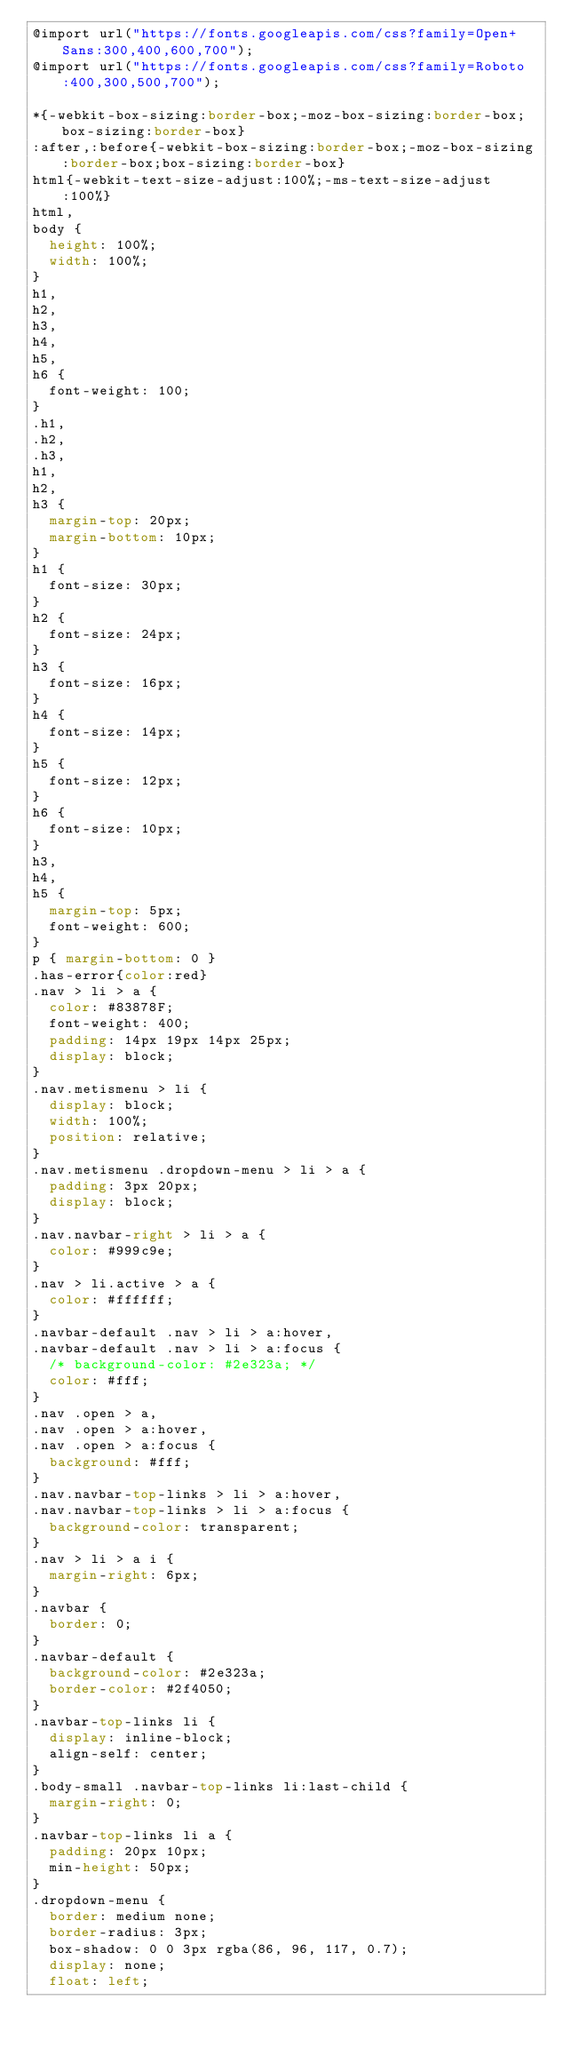<code> <loc_0><loc_0><loc_500><loc_500><_CSS_>@import url("https://fonts.googleapis.com/css?family=Open+Sans:300,400,600,700");
@import url("https://fonts.googleapis.com/css?family=Roboto:400,300,500,700");

*{-webkit-box-sizing:border-box;-moz-box-sizing:border-box;box-sizing:border-box}
:after,:before{-webkit-box-sizing:border-box;-moz-box-sizing:border-box;box-sizing:border-box}
html{-webkit-text-size-adjust:100%;-ms-text-size-adjust:100%}
html,
body {
  height: 100%;
  width: 100%;
}
h1,
h2,
h3,
h4,
h5,
h6 {
  font-weight: 100;
}
.h1,
.h2,
.h3,
h1,
h2,
h3 {
  margin-top: 20px;
  margin-bottom: 10px;
}
h1 {
  font-size: 30px;
}
h2 {
  font-size: 24px;
}
h3 {
  font-size: 16px;
}
h4 {
  font-size: 14px;
}
h5 {
  font-size: 12px;
}
h6 {
  font-size: 10px;
}
h3,
h4,
h5 {
  margin-top: 5px;
  font-weight: 600;
}
p { margin-bottom: 0 }
.has-error{color:red}
.nav > li > a {
  color: #83878F;
  font-weight: 400;
  padding: 14px 19px 14px 25px;
  display: block;
}
.nav.metismenu > li {
  display: block;
  width: 100%;
  position: relative;
}
.nav.metismenu .dropdown-menu > li > a {
  padding: 3px 20px;
  display: block;
}
.nav.navbar-right > li > a {
  color: #999c9e;
}
.nav > li.active > a {
  color: #ffffff;
}
.navbar-default .nav > li > a:hover,
.navbar-default .nav > li > a:focus {
  /* background-color: #2e323a; */
  color: #fff;
}
.nav .open > a,
.nav .open > a:hover,
.nav .open > a:focus {
  background: #fff;
}
.nav.navbar-top-links > li > a:hover,
.nav.navbar-top-links > li > a:focus {
  background-color: transparent;
}
.nav > li > a i {
  margin-right: 6px;
}
.navbar {
  border: 0;
}
.navbar-default {
  background-color: #2e323a;
  border-color: #2f4050;
}
.navbar-top-links li {
  display: inline-block;
  align-self: center;
}
.body-small .navbar-top-links li:last-child {
  margin-right: 0;
}
.navbar-top-links li a {
  padding: 20px 10px;
  min-height: 50px;
}
.dropdown-menu {
  border: medium none;
  border-radius: 3px;
  box-shadow: 0 0 3px rgba(86, 96, 117, 0.7);
  display: none;
  float: left;</code> 